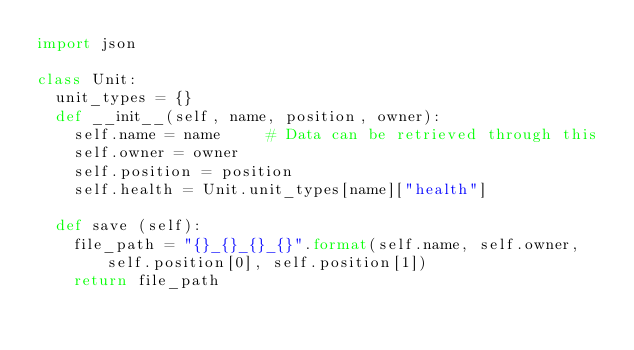Convert code to text. <code><loc_0><loc_0><loc_500><loc_500><_Python_>import json

class Unit:
	unit_types = {}
	def __init__(self, name, position, owner):
		self.name = name     # Data can be retrieved through this
		self.owner = owner
		self.position = position
		self.health = Unit.unit_types[name]["health"]

	def save (self):
		file_path = "{}_{}_{}_{}".format(self.name, self.owner, self.position[0], self.position[1])
		return file_path
</code> 